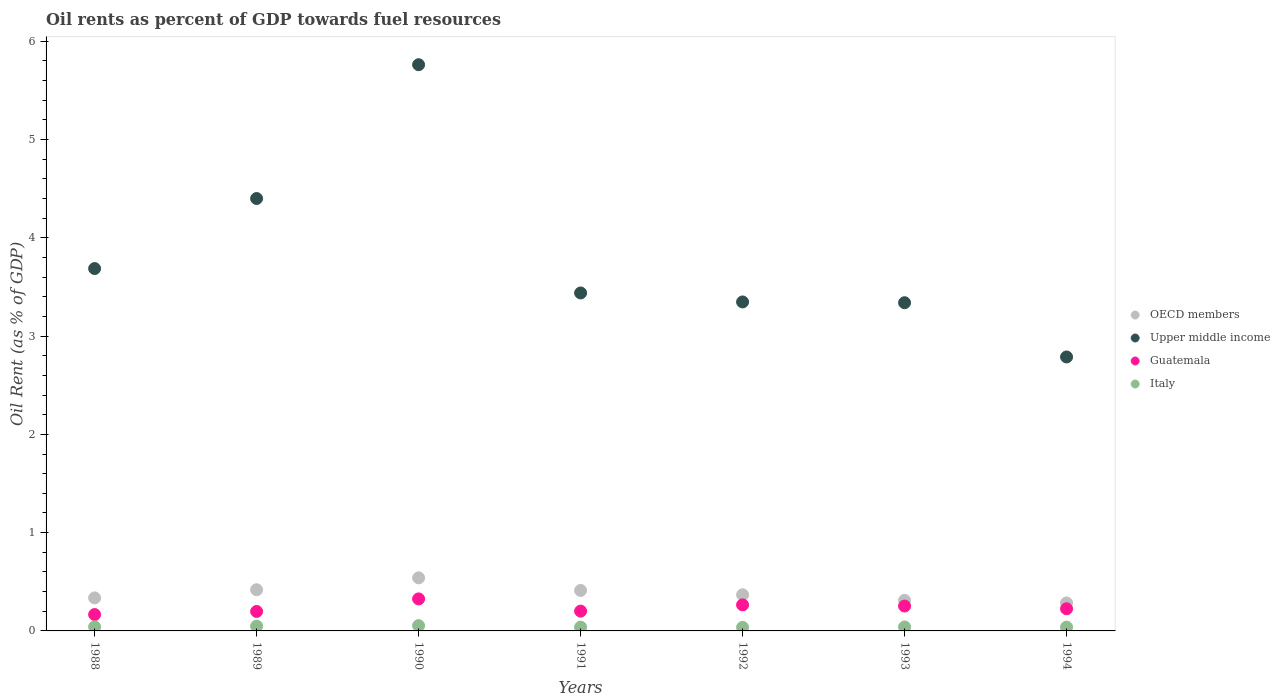How many different coloured dotlines are there?
Provide a short and direct response. 4. What is the oil rent in OECD members in 1993?
Provide a short and direct response. 0.31. Across all years, what is the maximum oil rent in Italy?
Ensure brevity in your answer.  0.05. Across all years, what is the minimum oil rent in Upper middle income?
Make the answer very short. 2.79. In which year was the oil rent in Guatemala minimum?
Ensure brevity in your answer.  1988. What is the total oil rent in Guatemala in the graph?
Keep it short and to the point. 1.64. What is the difference between the oil rent in Italy in 1988 and that in 1990?
Make the answer very short. -0.01. What is the difference between the oil rent in Italy in 1988 and the oil rent in Guatemala in 1990?
Make the answer very short. -0.28. What is the average oil rent in Guatemala per year?
Make the answer very short. 0.23. In the year 1990, what is the difference between the oil rent in Guatemala and oil rent in Italy?
Make the answer very short. 0.27. What is the ratio of the oil rent in Italy in 1991 to that in 1992?
Offer a terse response. 1.06. What is the difference between the highest and the second highest oil rent in Upper middle income?
Ensure brevity in your answer.  1.36. What is the difference between the highest and the lowest oil rent in Upper middle income?
Ensure brevity in your answer.  2.97. Is the sum of the oil rent in OECD members in 1992 and 1993 greater than the maximum oil rent in Italy across all years?
Make the answer very short. Yes. Is it the case that in every year, the sum of the oil rent in Italy and oil rent in OECD members  is greater than the sum of oil rent in Guatemala and oil rent in Upper middle income?
Your response must be concise. Yes. Is the oil rent in Upper middle income strictly greater than the oil rent in Italy over the years?
Keep it short and to the point. Yes. Is the oil rent in OECD members strictly less than the oil rent in Upper middle income over the years?
Keep it short and to the point. Yes. How many years are there in the graph?
Keep it short and to the point. 7. How many legend labels are there?
Your response must be concise. 4. What is the title of the graph?
Give a very brief answer. Oil rents as percent of GDP towards fuel resources. Does "Afghanistan" appear as one of the legend labels in the graph?
Give a very brief answer. No. What is the label or title of the X-axis?
Your response must be concise. Years. What is the label or title of the Y-axis?
Offer a very short reply. Oil Rent (as % of GDP). What is the Oil Rent (as % of GDP) in OECD members in 1988?
Ensure brevity in your answer.  0.34. What is the Oil Rent (as % of GDP) in Upper middle income in 1988?
Provide a succinct answer. 3.69. What is the Oil Rent (as % of GDP) of Guatemala in 1988?
Provide a short and direct response. 0.17. What is the Oil Rent (as % of GDP) of Italy in 1988?
Provide a short and direct response. 0.04. What is the Oil Rent (as % of GDP) of OECD members in 1989?
Make the answer very short. 0.42. What is the Oil Rent (as % of GDP) of Upper middle income in 1989?
Your answer should be compact. 4.4. What is the Oil Rent (as % of GDP) in Guatemala in 1989?
Provide a succinct answer. 0.2. What is the Oil Rent (as % of GDP) of Italy in 1989?
Provide a short and direct response. 0.05. What is the Oil Rent (as % of GDP) in OECD members in 1990?
Offer a terse response. 0.54. What is the Oil Rent (as % of GDP) of Upper middle income in 1990?
Make the answer very short. 5.76. What is the Oil Rent (as % of GDP) in Guatemala in 1990?
Your response must be concise. 0.33. What is the Oil Rent (as % of GDP) of Italy in 1990?
Provide a short and direct response. 0.05. What is the Oil Rent (as % of GDP) of OECD members in 1991?
Provide a succinct answer. 0.41. What is the Oil Rent (as % of GDP) in Upper middle income in 1991?
Your answer should be very brief. 3.44. What is the Oil Rent (as % of GDP) in Guatemala in 1991?
Give a very brief answer. 0.2. What is the Oil Rent (as % of GDP) of Italy in 1991?
Offer a terse response. 0.04. What is the Oil Rent (as % of GDP) of OECD members in 1992?
Give a very brief answer. 0.37. What is the Oil Rent (as % of GDP) in Upper middle income in 1992?
Give a very brief answer. 3.35. What is the Oil Rent (as % of GDP) in Guatemala in 1992?
Your response must be concise. 0.27. What is the Oil Rent (as % of GDP) in Italy in 1992?
Give a very brief answer. 0.04. What is the Oil Rent (as % of GDP) of OECD members in 1993?
Keep it short and to the point. 0.31. What is the Oil Rent (as % of GDP) in Upper middle income in 1993?
Offer a very short reply. 3.34. What is the Oil Rent (as % of GDP) of Guatemala in 1993?
Your answer should be compact. 0.25. What is the Oil Rent (as % of GDP) in Italy in 1993?
Give a very brief answer. 0.04. What is the Oil Rent (as % of GDP) in OECD members in 1994?
Keep it short and to the point. 0.28. What is the Oil Rent (as % of GDP) of Upper middle income in 1994?
Offer a very short reply. 2.79. What is the Oil Rent (as % of GDP) of Guatemala in 1994?
Offer a terse response. 0.23. What is the Oil Rent (as % of GDP) in Italy in 1994?
Make the answer very short. 0.04. Across all years, what is the maximum Oil Rent (as % of GDP) in OECD members?
Your response must be concise. 0.54. Across all years, what is the maximum Oil Rent (as % of GDP) of Upper middle income?
Your response must be concise. 5.76. Across all years, what is the maximum Oil Rent (as % of GDP) in Guatemala?
Offer a very short reply. 0.33. Across all years, what is the maximum Oil Rent (as % of GDP) in Italy?
Your answer should be compact. 0.05. Across all years, what is the minimum Oil Rent (as % of GDP) in OECD members?
Make the answer very short. 0.28. Across all years, what is the minimum Oil Rent (as % of GDP) in Upper middle income?
Make the answer very short. 2.79. Across all years, what is the minimum Oil Rent (as % of GDP) in Guatemala?
Offer a very short reply. 0.17. Across all years, what is the minimum Oil Rent (as % of GDP) of Italy?
Provide a short and direct response. 0.04. What is the total Oil Rent (as % of GDP) in OECD members in the graph?
Offer a terse response. 2.67. What is the total Oil Rent (as % of GDP) in Upper middle income in the graph?
Make the answer very short. 26.76. What is the total Oil Rent (as % of GDP) of Guatemala in the graph?
Make the answer very short. 1.64. What is the total Oil Rent (as % of GDP) of Italy in the graph?
Make the answer very short. 0.3. What is the difference between the Oil Rent (as % of GDP) in OECD members in 1988 and that in 1989?
Ensure brevity in your answer.  -0.08. What is the difference between the Oil Rent (as % of GDP) of Upper middle income in 1988 and that in 1989?
Your response must be concise. -0.71. What is the difference between the Oil Rent (as % of GDP) of Guatemala in 1988 and that in 1989?
Your answer should be very brief. -0.03. What is the difference between the Oil Rent (as % of GDP) of Italy in 1988 and that in 1989?
Offer a terse response. -0.01. What is the difference between the Oil Rent (as % of GDP) in OECD members in 1988 and that in 1990?
Make the answer very short. -0.2. What is the difference between the Oil Rent (as % of GDP) in Upper middle income in 1988 and that in 1990?
Your answer should be very brief. -2.07. What is the difference between the Oil Rent (as % of GDP) in Guatemala in 1988 and that in 1990?
Offer a terse response. -0.16. What is the difference between the Oil Rent (as % of GDP) in Italy in 1988 and that in 1990?
Keep it short and to the point. -0.01. What is the difference between the Oil Rent (as % of GDP) in OECD members in 1988 and that in 1991?
Your answer should be compact. -0.08. What is the difference between the Oil Rent (as % of GDP) of Upper middle income in 1988 and that in 1991?
Provide a succinct answer. 0.25. What is the difference between the Oil Rent (as % of GDP) of Guatemala in 1988 and that in 1991?
Your answer should be compact. -0.03. What is the difference between the Oil Rent (as % of GDP) in Italy in 1988 and that in 1991?
Give a very brief answer. 0. What is the difference between the Oil Rent (as % of GDP) of OECD members in 1988 and that in 1992?
Your answer should be compact. -0.03. What is the difference between the Oil Rent (as % of GDP) of Upper middle income in 1988 and that in 1992?
Give a very brief answer. 0.34. What is the difference between the Oil Rent (as % of GDP) in Guatemala in 1988 and that in 1992?
Your answer should be compact. -0.1. What is the difference between the Oil Rent (as % of GDP) in Italy in 1988 and that in 1992?
Ensure brevity in your answer.  0.01. What is the difference between the Oil Rent (as % of GDP) in OECD members in 1988 and that in 1993?
Offer a terse response. 0.03. What is the difference between the Oil Rent (as % of GDP) in Upper middle income in 1988 and that in 1993?
Keep it short and to the point. 0.35. What is the difference between the Oil Rent (as % of GDP) of Guatemala in 1988 and that in 1993?
Offer a very short reply. -0.09. What is the difference between the Oil Rent (as % of GDP) of Italy in 1988 and that in 1993?
Make the answer very short. 0. What is the difference between the Oil Rent (as % of GDP) in OECD members in 1988 and that in 1994?
Keep it short and to the point. 0.05. What is the difference between the Oil Rent (as % of GDP) of Upper middle income in 1988 and that in 1994?
Your answer should be compact. 0.9. What is the difference between the Oil Rent (as % of GDP) of Guatemala in 1988 and that in 1994?
Ensure brevity in your answer.  -0.06. What is the difference between the Oil Rent (as % of GDP) in Italy in 1988 and that in 1994?
Provide a succinct answer. 0. What is the difference between the Oil Rent (as % of GDP) in OECD members in 1989 and that in 1990?
Give a very brief answer. -0.12. What is the difference between the Oil Rent (as % of GDP) in Upper middle income in 1989 and that in 1990?
Offer a terse response. -1.36. What is the difference between the Oil Rent (as % of GDP) of Guatemala in 1989 and that in 1990?
Your answer should be compact. -0.13. What is the difference between the Oil Rent (as % of GDP) of Italy in 1989 and that in 1990?
Your answer should be compact. -0.01. What is the difference between the Oil Rent (as % of GDP) of OECD members in 1989 and that in 1991?
Your answer should be very brief. 0.01. What is the difference between the Oil Rent (as % of GDP) in Upper middle income in 1989 and that in 1991?
Your answer should be very brief. 0.96. What is the difference between the Oil Rent (as % of GDP) of Guatemala in 1989 and that in 1991?
Provide a short and direct response. -0. What is the difference between the Oil Rent (as % of GDP) in Italy in 1989 and that in 1991?
Your answer should be very brief. 0.01. What is the difference between the Oil Rent (as % of GDP) in OECD members in 1989 and that in 1992?
Your response must be concise. 0.05. What is the difference between the Oil Rent (as % of GDP) in Upper middle income in 1989 and that in 1992?
Keep it short and to the point. 1.05. What is the difference between the Oil Rent (as % of GDP) in Guatemala in 1989 and that in 1992?
Provide a succinct answer. -0.07. What is the difference between the Oil Rent (as % of GDP) in Italy in 1989 and that in 1992?
Offer a terse response. 0.01. What is the difference between the Oil Rent (as % of GDP) in OECD members in 1989 and that in 1993?
Offer a terse response. 0.11. What is the difference between the Oil Rent (as % of GDP) of Upper middle income in 1989 and that in 1993?
Your answer should be compact. 1.06. What is the difference between the Oil Rent (as % of GDP) in Guatemala in 1989 and that in 1993?
Ensure brevity in your answer.  -0.05. What is the difference between the Oil Rent (as % of GDP) in Italy in 1989 and that in 1993?
Keep it short and to the point. 0.01. What is the difference between the Oil Rent (as % of GDP) in OECD members in 1989 and that in 1994?
Your response must be concise. 0.13. What is the difference between the Oil Rent (as % of GDP) of Upper middle income in 1989 and that in 1994?
Make the answer very short. 1.61. What is the difference between the Oil Rent (as % of GDP) of Guatemala in 1989 and that in 1994?
Ensure brevity in your answer.  -0.03. What is the difference between the Oil Rent (as % of GDP) in Italy in 1989 and that in 1994?
Keep it short and to the point. 0.01. What is the difference between the Oil Rent (as % of GDP) of OECD members in 1990 and that in 1991?
Give a very brief answer. 0.13. What is the difference between the Oil Rent (as % of GDP) of Upper middle income in 1990 and that in 1991?
Your answer should be very brief. 2.32. What is the difference between the Oil Rent (as % of GDP) of Guatemala in 1990 and that in 1991?
Offer a very short reply. 0.12. What is the difference between the Oil Rent (as % of GDP) in Italy in 1990 and that in 1991?
Ensure brevity in your answer.  0.02. What is the difference between the Oil Rent (as % of GDP) in OECD members in 1990 and that in 1992?
Your answer should be very brief. 0.17. What is the difference between the Oil Rent (as % of GDP) of Upper middle income in 1990 and that in 1992?
Offer a very short reply. 2.41. What is the difference between the Oil Rent (as % of GDP) of Guatemala in 1990 and that in 1992?
Your answer should be compact. 0.06. What is the difference between the Oil Rent (as % of GDP) in Italy in 1990 and that in 1992?
Provide a short and direct response. 0.02. What is the difference between the Oil Rent (as % of GDP) of OECD members in 1990 and that in 1993?
Offer a terse response. 0.23. What is the difference between the Oil Rent (as % of GDP) in Upper middle income in 1990 and that in 1993?
Ensure brevity in your answer.  2.42. What is the difference between the Oil Rent (as % of GDP) in Guatemala in 1990 and that in 1993?
Your answer should be compact. 0.07. What is the difference between the Oil Rent (as % of GDP) in Italy in 1990 and that in 1993?
Give a very brief answer. 0.01. What is the difference between the Oil Rent (as % of GDP) in OECD members in 1990 and that in 1994?
Offer a very short reply. 0.26. What is the difference between the Oil Rent (as % of GDP) in Upper middle income in 1990 and that in 1994?
Offer a terse response. 2.97. What is the difference between the Oil Rent (as % of GDP) of Guatemala in 1990 and that in 1994?
Your answer should be very brief. 0.1. What is the difference between the Oil Rent (as % of GDP) in Italy in 1990 and that in 1994?
Make the answer very short. 0.02. What is the difference between the Oil Rent (as % of GDP) in OECD members in 1991 and that in 1992?
Your answer should be compact. 0.04. What is the difference between the Oil Rent (as % of GDP) in Upper middle income in 1991 and that in 1992?
Offer a very short reply. 0.09. What is the difference between the Oil Rent (as % of GDP) in Guatemala in 1991 and that in 1992?
Your answer should be compact. -0.06. What is the difference between the Oil Rent (as % of GDP) of Italy in 1991 and that in 1992?
Offer a very short reply. 0. What is the difference between the Oil Rent (as % of GDP) in OECD members in 1991 and that in 1993?
Provide a succinct answer. 0.1. What is the difference between the Oil Rent (as % of GDP) in Upper middle income in 1991 and that in 1993?
Make the answer very short. 0.1. What is the difference between the Oil Rent (as % of GDP) of Guatemala in 1991 and that in 1993?
Make the answer very short. -0.05. What is the difference between the Oil Rent (as % of GDP) of Italy in 1991 and that in 1993?
Keep it short and to the point. -0. What is the difference between the Oil Rent (as % of GDP) of OECD members in 1991 and that in 1994?
Keep it short and to the point. 0.13. What is the difference between the Oil Rent (as % of GDP) of Upper middle income in 1991 and that in 1994?
Keep it short and to the point. 0.65. What is the difference between the Oil Rent (as % of GDP) in Guatemala in 1991 and that in 1994?
Make the answer very short. -0.02. What is the difference between the Oil Rent (as % of GDP) in Italy in 1991 and that in 1994?
Offer a terse response. 0. What is the difference between the Oil Rent (as % of GDP) of OECD members in 1992 and that in 1993?
Make the answer very short. 0.06. What is the difference between the Oil Rent (as % of GDP) in Upper middle income in 1992 and that in 1993?
Provide a succinct answer. 0.01. What is the difference between the Oil Rent (as % of GDP) in Guatemala in 1992 and that in 1993?
Offer a very short reply. 0.01. What is the difference between the Oil Rent (as % of GDP) in Italy in 1992 and that in 1993?
Offer a terse response. -0. What is the difference between the Oil Rent (as % of GDP) of OECD members in 1992 and that in 1994?
Offer a very short reply. 0.08. What is the difference between the Oil Rent (as % of GDP) of Upper middle income in 1992 and that in 1994?
Provide a succinct answer. 0.56. What is the difference between the Oil Rent (as % of GDP) in Guatemala in 1992 and that in 1994?
Offer a very short reply. 0.04. What is the difference between the Oil Rent (as % of GDP) in Italy in 1992 and that in 1994?
Offer a very short reply. -0. What is the difference between the Oil Rent (as % of GDP) in OECD members in 1993 and that in 1994?
Keep it short and to the point. 0.03. What is the difference between the Oil Rent (as % of GDP) in Upper middle income in 1993 and that in 1994?
Ensure brevity in your answer.  0.55. What is the difference between the Oil Rent (as % of GDP) of Guatemala in 1993 and that in 1994?
Offer a terse response. 0.03. What is the difference between the Oil Rent (as % of GDP) of Italy in 1993 and that in 1994?
Offer a terse response. 0. What is the difference between the Oil Rent (as % of GDP) of OECD members in 1988 and the Oil Rent (as % of GDP) of Upper middle income in 1989?
Offer a terse response. -4.06. What is the difference between the Oil Rent (as % of GDP) of OECD members in 1988 and the Oil Rent (as % of GDP) of Guatemala in 1989?
Provide a short and direct response. 0.14. What is the difference between the Oil Rent (as % of GDP) of OECD members in 1988 and the Oil Rent (as % of GDP) of Italy in 1989?
Give a very brief answer. 0.29. What is the difference between the Oil Rent (as % of GDP) in Upper middle income in 1988 and the Oil Rent (as % of GDP) in Guatemala in 1989?
Keep it short and to the point. 3.49. What is the difference between the Oil Rent (as % of GDP) in Upper middle income in 1988 and the Oil Rent (as % of GDP) in Italy in 1989?
Your answer should be compact. 3.64. What is the difference between the Oil Rent (as % of GDP) in Guatemala in 1988 and the Oil Rent (as % of GDP) in Italy in 1989?
Make the answer very short. 0.12. What is the difference between the Oil Rent (as % of GDP) in OECD members in 1988 and the Oil Rent (as % of GDP) in Upper middle income in 1990?
Keep it short and to the point. -5.43. What is the difference between the Oil Rent (as % of GDP) in OECD members in 1988 and the Oil Rent (as % of GDP) in Guatemala in 1990?
Your answer should be compact. 0.01. What is the difference between the Oil Rent (as % of GDP) in OECD members in 1988 and the Oil Rent (as % of GDP) in Italy in 1990?
Your response must be concise. 0.28. What is the difference between the Oil Rent (as % of GDP) in Upper middle income in 1988 and the Oil Rent (as % of GDP) in Guatemala in 1990?
Give a very brief answer. 3.36. What is the difference between the Oil Rent (as % of GDP) of Upper middle income in 1988 and the Oil Rent (as % of GDP) of Italy in 1990?
Your answer should be very brief. 3.63. What is the difference between the Oil Rent (as % of GDP) of Guatemala in 1988 and the Oil Rent (as % of GDP) of Italy in 1990?
Keep it short and to the point. 0.11. What is the difference between the Oil Rent (as % of GDP) in OECD members in 1988 and the Oil Rent (as % of GDP) in Upper middle income in 1991?
Provide a short and direct response. -3.1. What is the difference between the Oil Rent (as % of GDP) of OECD members in 1988 and the Oil Rent (as % of GDP) of Guatemala in 1991?
Ensure brevity in your answer.  0.13. What is the difference between the Oil Rent (as % of GDP) in OECD members in 1988 and the Oil Rent (as % of GDP) in Italy in 1991?
Make the answer very short. 0.3. What is the difference between the Oil Rent (as % of GDP) of Upper middle income in 1988 and the Oil Rent (as % of GDP) of Guatemala in 1991?
Ensure brevity in your answer.  3.49. What is the difference between the Oil Rent (as % of GDP) of Upper middle income in 1988 and the Oil Rent (as % of GDP) of Italy in 1991?
Ensure brevity in your answer.  3.65. What is the difference between the Oil Rent (as % of GDP) in Guatemala in 1988 and the Oil Rent (as % of GDP) in Italy in 1991?
Offer a terse response. 0.13. What is the difference between the Oil Rent (as % of GDP) of OECD members in 1988 and the Oil Rent (as % of GDP) of Upper middle income in 1992?
Ensure brevity in your answer.  -3.01. What is the difference between the Oil Rent (as % of GDP) of OECD members in 1988 and the Oil Rent (as % of GDP) of Guatemala in 1992?
Your answer should be compact. 0.07. What is the difference between the Oil Rent (as % of GDP) of OECD members in 1988 and the Oil Rent (as % of GDP) of Italy in 1992?
Offer a very short reply. 0.3. What is the difference between the Oil Rent (as % of GDP) of Upper middle income in 1988 and the Oil Rent (as % of GDP) of Guatemala in 1992?
Your answer should be compact. 3.42. What is the difference between the Oil Rent (as % of GDP) of Upper middle income in 1988 and the Oil Rent (as % of GDP) of Italy in 1992?
Provide a succinct answer. 3.65. What is the difference between the Oil Rent (as % of GDP) in Guatemala in 1988 and the Oil Rent (as % of GDP) in Italy in 1992?
Keep it short and to the point. 0.13. What is the difference between the Oil Rent (as % of GDP) in OECD members in 1988 and the Oil Rent (as % of GDP) in Upper middle income in 1993?
Your answer should be very brief. -3. What is the difference between the Oil Rent (as % of GDP) in OECD members in 1988 and the Oil Rent (as % of GDP) in Guatemala in 1993?
Make the answer very short. 0.08. What is the difference between the Oil Rent (as % of GDP) of OECD members in 1988 and the Oil Rent (as % of GDP) of Italy in 1993?
Provide a short and direct response. 0.3. What is the difference between the Oil Rent (as % of GDP) in Upper middle income in 1988 and the Oil Rent (as % of GDP) in Guatemala in 1993?
Give a very brief answer. 3.43. What is the difference between the Oil Rent (as % of GDP) of Upper middle income in 1988 and the Oil Rent (as % of GDP) of Italy in 1993?
Offer a very short reply. 3.65. What is the difference between the Oil Rent (as % of GDP) in Guatemala in 1988 and the Oil Rent (as % of GDP) in Italy in 1993?
Keep it short and to the point. 0.13. What is the difference between the Oil Rent (as % of GDP) in OECD members in 1988 and the Oil Rent (as % of GDP) in Upper middle income in 1994?
Provide a succinct answer. -2.45. What is the difference between the Oil Rent (as % of GDP) in OECD members in 1988 and the Oil Rent (as % of GDP) in Guatemala in 1994?
Your answer should be very brief. 0.11. What is the difference between the Oil Rent (as % of GDP) of OECD members in 1988 and the Oil Rent (as % of GDP) of Italy in 1994?
Your answer should be compact. 0.3. What is the difference between the Oil Rent (as % of GDP) of Upper middle income in 1988 and the Oil Rent (as % of GDP) of Guatemala in 1994?
Your response must be concise. 3.46. What is the difference between the Oil Rent (as % of GDP) of Upper middle income in 1988 and the Oil Rent (as % of GDP) of Italy in 1994?
Your answer should be very brief. 3.65. What is the difference between the Oil Rent (as % of GDP) of Guatemala in 1988 and the Oil Rent (as % of GDP) of Italy in 1994?
Your answer should be compact. 0.13. What is the difference between the Oil Rent (as % of GDP) in OECD members in 1989 and the Oil Rent (as % of GDP) in Upper middle income in 1990?
Keep it short and to the point. -5.34. What is the difference between the Oil Rent (as % of GDP) in OECD members in 1989 and the Oil Rent (as % of GDP) in Guatemala in 1990?
Your answer should be compact. 0.09. What is the difference between the Oil Rent (as % of GDP) of OECD members in 1989 and the Oil Rent (as % of GDP) of Italy in 1990?
Ensure brevity in your answer.  0.36. What is the difference between the Oil Rent (as % of GDP) of Upper middle income in 1989 and the Oil Rent (as % of GDP) of Guatemala in 1990?
Provide a succinct answer. 4.07. What is the difference between the Oil Rent (as % of GDP) of Upper middle income in 1989 and the Oil Rent (as % of GDP) of Italy in 1990?
Your answer should be compact. 4.35. What is the difference between the Oil Rent (as % of GDP) in Guatemala in 1989 and the Oil Rent (as % of GDP) in Italy in 1990?
Provide a succinct answer. 0.14. What is the difference between the Oil Rent (as % of GDP) in OECD members in 1989 and the Oil Rent (as % of GDP) in Upper middle income in 1991?
Your response must be concise. -3.02. What is the difference between the Oil Rent (as % of GDP) of OECD members in 1989 and the Oil Rent (as % of GDP) of Guatemala in 1991?
Make the answer very short. 0.22. What is the difference between the Oil Rent (as % of GDP) of OECD members in 1989 and the Oil Rent (as % of GDP) of Italy in 1991?
Provide a succinct answer. 0.38. What is the difference between the Oil Rent (as % of GDP) of Upper middle income in 1989 and the Oil Rent (as % of GDP) of Guatemala in 1991?
Offer a terse response. 4.2. What is the difference between the Oil Rent (as % of GDP) of Upper middle income in 1989 and the Oil Rent (as % of GDP) of Italy in 1991?
Your response must be concise. 4.36. What is the difference between the Oil Rent (as % of GDP) of Guatemala in 1989 and the Oil Rent (as % of GDP) of Italy in 1991?
Provide a succinct answer. 0.16. What is the difference between the Oil Rent (as % of GDP) of OECD members in 1989 and the Oil Rent (as % of GDP) of Upper middle income in 1992?
Make the answer very short. -2.93. What is the difference between the Oil Rent (as % of GDP) in OECD members in 1989 and the Oil Rent (as % of GDP) in Guatemala in 1992?
Ensure brevity in your answer.  0.15. What is the difference between the Oil Rent (as % of GDP) in OECD members in 1989 and the Oil Rent (as % of GDP) in Italy in 1992?
Your answer should be very brief. 0.38. What is the difference between the Oil Rent (as % of GDP) of Upper middle income in 1989 and the Oil Rent (as % of GDP) of Guatemala in 1992?
Make the answer very short. 4.13. What is the difference between the Oil Rent (as % of GDP) in Upper middle income in 1989 and the Oil Rent (as % of GDP) in Italy in 1992?
Offer a very short reply. 4.36. What is the difference between the Oil Rent (as % of GDP) in Guatemala in 1989 and the Oil Rent (as % of GDP) in Italy in 1992?
Ensure brevity in your answer.  0.16. What is the difference between the Oil Rent (as % of GDP) of OECD members in 1989 and the Oil Rent (as % of GDP) of Upper middle income in 1993?
Make the answer very short. -2.92. What is the difference between the Oil Rent (as % of GDP) in OECD members in 1989 and the Oil Rent (as % of GDP) in Guatemala in 1993?
Ensure brevity in your answer.  0.17. What is the difference between the Oil Rent (as % of GDP) in OECD members in 1989 and the Oil Rent (as % of GDP) in Italy in 1993?
Give a very brief answer. 0.38. What is the difference between the Oil Rent (as % of GDP) of Upper middle income in 1989 and the Oil Rent (as % of GDP) of Guatemala in 1993?
Provide a succinct answer. 4.15. What is the difference between the Oil Rent (as % of GDP) in Upper middle income in 1989 and the Oil Rent (as % of GDP) in Italy in 1993?
Offer a very short reply. 4.36. What is the difference between the Oil Rent (as % of GDP) in Guatemala in 1989 and the Oil Rent (as % of GDP) in Italy in 1993?
Provide a short and direct response. 0.16. What is the difference between the Oil Rent (as % of GDP) in OECD members in 1989 and the Oil Rent (as % of GDP) in Upper middle income in 1994?
Make the answer very short. -2.37. What is the difference between the Oil Rent (as % of GDP) in OECD members in 1989 and the Oil Rent (as % of GDP) in Guatemala in 1994?
Offer a terse response. 0.19. What is the difference between the Oil Rent (as % of GDP) of OECD members in 1989 and the Oil Rent (as % of GDP) of Italy in 1994?
Ensure brevity in your answer.  0.38. What is the difference between the Oil Rent (as % of GDP) in Upper middle income in 1989 and the Oil Rent (as % of GDP) in Guatemala in 1994?
Your response must be concise. 4.17. What is the difference between the Oil Rent (as % of GDP) in Upper middle income in 1989 and the Oil Rent (as % of GDP) in Italy in 1994?
Ensure brevity in your answer.  4.36. What is the difference between the Oil Rent (as % of GDP) in Guatemala in 1989 and the Oil Rent (as % of GDP) in Italy in 1994?
Ensure brevity in your answer.  0.16. What is the difference between the Oil Rent (as % of GDP) of OECD members in 1990 and the Oil Rent (as % of GDP) of Upper middle income in 1991?
Keep it short and to the point. -2.9. What is the difference between the Oil Rent (as % of GDP) of OECD members in 1990 and the Oil Rent (as % of GDP) of Guatemala in 1991?
Offer a terse response. 0.34. What is the difference between the Oil Rent (as % of GDP) of OECD members in 1990 and the Oil Rent (as % of GDP) of Italy in 1991?
Make the answer very short. 0.5. What is the difference between the Oil Rent (as % of GDP) in Upper middle income in 1990 and the Oil Rent (as % of GDP) in Guatemala in 1991?
Offer a very short reply. 5.56. What is the difference between the Oil Rent (as % of GDP) of Upper middle income in 1990 and the Oil Rent (as % of GDP) of Italy in 1991?
Provide a short and direct response. 5.72. What is the difference between the Oil Rent (as % of GDP) in Guatemala in 1990 and the Oil Rent (as % of GDP) in Italy in 1991?
Your answer should be very brief. 0.29. What is the difference between the Oil Rent (as % of GDP) in OECD members in 1990 and the Oil Rent (as % of GDP) in Upper middle income in 1992?
Your answer should be compact. -2.81. What is the difference between the Oil Rent (as % of GDP) of OECD members in 1990 and the Oil Rent (as % of GDP) of Guatemala in 1992?
Offer a very short reply. 0.28. What is the difference between the Oil Rent (as % of GDP) of OECD members in 1990 and the Oil Rent (as % of GDP) of Italy in 1992?
Provide a succinct answer. 0.5. What is the difference between the Oil Rent (as % of GDP) of Upper middle income in 1990 and the Oil Rent (as % of GDP) of Guatemala in 1992?
Your answer should be very brief. 5.5. What is the difference between the Oil Rent (as % of GDP) in Upper middle income in 1990 and the Oil Rent (as % of GDP) in Italy in 1992?
Give a very brief answer. 5.73. What is the difference between the Oil Rent (as % of GDP) of Guatemala in 1990 and the Oil Rent (as % of GDP) of Italy in 1992?
Keep it short and to the point. 0.29. What is the difference between the Oil Rent (as % of GDP) in OECD members in 1990 and the Oil Rent (as % of GDP) in Upper middle income in 1993?
Your response must be concise. -2.8. What is the difference between the Oil Rent (as % of GDP) of OECD members in 1990 and the Oil Rent (as % of GDP) of Guatemala in 1993?
Make the answer very short. 0.29. What is the difference between the Oil Rent (as % of GDP) of OECD members in 1990 and the Oil Rent (as % of GDP) of Italy in 1993?
Make the answer very short. 0.5. What is the difference between the Oil Rent (as % of GDP) in Upper middle income in 1990 and the Oil Rent (as % of GDP) in Guatemala in 1993?
Make the answer very short. 5.51. What is the difference between the Oil Rent (as % of GDP) of Upper middle income in 1990 and the Oil Rent (as % of GDP) of Italy in 1993?
Provide a succinct answer. 5.72. What is the difference between the Oil Rent (as % of GDP) of Guatemala in 1990 and the Oil Rent (as % of GDP) of Italy in 1993?
Provide a short and direct response. 0.29. What is the difference between the Oil Rent (as % of GDP) in OECD members in 1990 and the Oil Rent (as % of GDP) in Upper middle income in 1994?
Ensure brevity in your answer.  -2.25. What is the difference between the Oil Rent (as % of GDP) in OECD members in 1990 and the Oil Rent (as % of GDP) in Guatemala in 1994?
Your answer should be very brief. 0.31. What is the difference between the Oil Rent (as % of GDP) of OECD members in 1990 and the Oil Rent (as % of GDP) of Italy in 1994?
Offer a very short reply. 0.5. What is the difference between the Oil Rent (as % of GDP) in Upper middle income in 1990 and the Oil Rent (as % of GDP) in Guatemala in 1994?
Keep it short and to the point. 5.54. What is the difference between the Oil Rent (as % of GDP) of Upper middle income in 1990 and the Oil Rent (as % of GDP) of Italy in 1994?
Offer a very short reply. 5.72. What is the difference between the Oil Rent (as % of GDP) of Guatemala in 1990 and the Oil Rent (as % of GDP) of Italy in 1994?
Offer a terse response. 0.29. What is the difference between the Oil Rent (as % of GDP) in OECD members in 1991 and the Oil Rent (as % of GDP) in Upper middle income in 1992?
Your answer should be very brief. -2.94. What is the difference between the Oil Rent (as % of GDP) of OECD members in 1991 and the Oil Rent (as % of GDP) of Guatemala in 1992?
Provide a succinct answer. 0.15. What is the difference between the Oil Rent (as % of GDP) in OECD members in 1991 and the Oil Rent (as % of GDP) in Italy in 1992?
Your answer should be very brief. 0.38. What is the difference between the Oil Rent (as % of GDP) of Upper middle income in 1991 and the Oil Rent (as % of GDP) of Guatemala in 1992?
Your answer should be very brief. 3.17. What is the difference between the Oil Rent (as % of GDP) of Upper middle income in 1991 and the Oil Rent (as % of GDP) of Italy in 1992?
Provide a succinct answer. 3.4. What is the difference between the Oil Rent (as % of GDP) of Guatemala in 1991 and the Oil Rent (as % of GDP) of Italy in 1992?
Keep it short and to the point. 0.17. What is the difference between the Oil Rent (as % of GDP) of OECD members in 1991 and the Oil Rent (as % of GDP) of Upper middle income in 1993?
Your response must be concise. -2.93. What is the difference between the Oil Rent (as % of GDP) of OECD members in 1991 and the Oil Rent (as % of GDP) of Guatemala in 1993?
Offer a terse response. 0.16. What is the difference between the Oil Rent (as % of GDP) in OECD members in 1991 and the Oil Rent (as % of GDP) in Italy in 1993?
Make the answer very short. 0.37. What is the difference between the Oil Rent (as % of GDP) in Upper middle income in 1991 and the Oil Rent (as % of GDP) in Guatemala in 1993?
Your answer should be compact. 3.19. What is the difference between the Oil Rent (as % of GDP) of Upper middle income in 1991 and the Oil Rent (as % of GDP) of Italy in 1993?
Keep it short and to the point. 3.4. What is the difference between the Oil Rent (as % of GDP) of Guatemala in 1991 and the Oil Rent (as % of GDP) of Italy in 1993?
Keep it short and to the point. 0.16. What is the difference between the Oil Rent (as % of GDP) of OECD members in 1991 and the Oil Rent (as % of GDP) of Upper middle income in 1994?
Make the answer very short. -2.38. What is the difference between the Oil Rent (as % of GDP) of OECD members in 1991 and the Oil Rent (as % of GDP) of Guatemala in 1994?
Offer a very short reply. 0.19. What is the difference between the Oil Rent (as % of GDP) in OECD members in 1991 and the Oil Rent (as % of GDP) in Italy in 1994?
Make the answer very short. 0.37. What is the difference between the Oil Rent (as % of GDP) in Upper middle income in 1991 and the Oil Rent (as % of GDP) in Guatemala in 1994?
Offer a very short reply. 3.21. What is the difference between the Oil Rent (as % of GDP) in Upper middle income in 1991 and the Oil Rent (as % of GDP) in Italy in 1994?
Your answer should be compact. 3.4. What is the difference between the Oil Rent (as % of GDP) in Guatemala in 1991 and the Oil Rent (as % of GDP) in Italy in 1994?
Ensure brevity in your answer.  0.16. What is the difference between the Oil Rent (as % of GDP) in OECD members in 1992 and the Oil Rent (as % of GDP) in Upper middle income in 1993?
Your answer should be compact. -2.97. What is the difference between the Oil Rent (as % of GDP) in OECD members in 1992 and the Oil Rent (as % of GDP) in Guatemala in 1993?
Make the answer very short. 0.11. What is the difference between the Oil Rent (as % of GDP) of OECD members in 1992 and the Oil Rent (as % of GDP) of Italy in 1993?
Offer a terse response. 0.33. What is the difference between the Oil Rent (as % of GDP) of Upper middle income in 1992 and the Oil Rent (as % of GDP) of Guatemala in 1993?
Ensure brevity in your answer.  3.09. What is the difference between the Oil Rent (as % of GDP) in Upper middle income in 1992 and the Oil Rent (as % of GDP) in Italy in 1993?
Offer a terse response. 3.31. What is the difference between the Oil Rent (as % of GDP) in Guatemala in 1992 and the Oil Rent (as % of GDP) in Italy in 1993?
Make the answer very short. 0.22. What is the difference between the Oil Rent (as % of GDP) of OECD members in 1992 and the Oil Rent (as % of GDP) of Upper middle income in 1994?
Provide a short and direct response. -2.42. What is the difference between the Oil Rent (as % of GDP) of OECD members in 1992 and the Oil Rent (as % of GDP) of Guatemala in 1994?
Your answer should be very brief. 0.14. What is the difference between the Oil Rent (as % of GDP) in OECD members in 1992 and the Oil Rent (as % of GDP) in Italy in 1994?
Ensure brevity in your answer.  0.33. What is the difference between the Oil Rent (as % of GDP) of Upper middle income in 1992 and the Oil Rent (as % of GDP) of Guatemala in 1994?
Ensure brevity in your answer.  3.12. What is the difference between the Oil Rent (as % of GDP) of Upper middle income in 1992 and the Oil Rent (as % of GDP) of Italy in 1994?
Provide a short and direct response. 3.31. What is the difference between the Oil Rent (as % of GDP) of Guatemala in 1992 and the Oil Rent (as % of GDP) of Italy in 1994?
Offer a terse response. 0.23. What is the difference between the Oil Rent (as % of GDP) of OECD members in 1993 and the Oil Rent (as % of GDP) of Upper middle income in 1994?
Offer a very short reply. -2.48. What is the difference between the Oil Rent (as % of GDP) of OECD members in 1993 and the Oil Rent (as % of GDP) of Guatemala in 1994?
Your answer should be compact. 0.09. What is the difference between the Oil Rent (as % of GDP) in OECD members in 1993 and the Oil Rent (as % of GDP) in Italy in 1994?
Keep it short and to the point. 0.27. What is the difference between the Oil Rent (as % of GDP) in Upper middle income in 1993 and the Oil Rent (as % of GDP) in Guatemala in 1994?
Ensure brevity in your answer.  3.11. What is the difference between the Oil Rent (as % of GDP) of Upper middle income in 1993 and the Oil Rent (as % of GDP) of Italy in 1994?
Your answer should be compact. 3.3. What is the difference between the Oil Rent (as % of GDP) in Guatemala in 1993 and the Oil Rent (as % of GDP) in Italy in 1994?
Your response must be concise. 0.21. What is the average Oil Rent (as % of GDP) in OECD members per year?
Make the answer very short. 0.38. What is the average Oil Rent (as % of GDP) in Upper middle income per year?
Make the answer very short. 3.82. What is the average Oil Rent (as % of GDP) of Guatemala per year?
Offer a very short reply. 0.23. What is the average Oil Rent (as % of GDP) of Italy per year?
Your response must be concise. 0.04. In the year 1988, what is the difference between the Oil Rent (as % of GDP) of OECD members and Oil Rent (as % of GDP) of Upper middle income?
Give a very brief answer. -3.35. In the year 1988, what is the difference between the Oil Rent (as % of GDP) of OECD members and Oil Rent (as % of GDP) of Guatemala?
Your response must be concise. 0.17. In the year 1988, what is the difference between the Oil Rent (as % of GDP) in OECD members and Oil Rent (as % of GDP) in Italy?
Ensure brevity in your answer.  0.29. In the year 1988, what is the difference between the Oil Rent (as % of GDP) in Upper middle income and Oil Rent (as % of GDP) in Guatemala?
Keep it short and to the point. 3.52. In the year 1988, what is the difference between the Oil Rent (as % of GDP) of Upper middle income and Oil Rent (as % of GDP) of Italy?
Give a very brief answer. 3.65. In the year 1988, what is the difference between the Oil Rent (as % of GDP) of Guatemala and Oil Rent (as % of GDP) of Italy?
Your answer should be very brief. 0.13. In the year 1989, what is the difference between the Oil Rent (as % of GDP) of OECD members and Oil Rent (as % of GDP) of Upper middle income?
Provide a succinct answer. -3.98. In the year 1989, what is the difference between the Oil Rent (as % of GDP) in OECD members and Oil Rent (as % of GDP) in Guatemala?
Keep it short and to the point. 0.22. In the year 1989, what is the difference between the Oil Rent (as % of GDP) of OECD members and Oil Rent (as % of GDP) of Italy?
Provide a short and direct response. 0.37. In the year 1989, what is the difference between the Oil Rent (as % of GDP) of Upper middle income and Oil Rent (as % of GDP) of Guatemala?
Provide a short and direct response. 4.2. In the year 1989, what is the difference between the Oil Rent (as % of GDP) of Upper middle income and Oil Rent (as % of GDP) of Italy?
Your answer should be compact. 4.35. In the year 1989, what is the difference between the Oil Rent (as % of GDP) of Guatemala and Oil Rent (as % of GDP) of Italy?
Offer a terse response. 0.15. In the year 1990, what is the difference between the Oil Rent (as % of GDP) in OECD members and Oil Rent (as % of GDP) in Upper middle income?
Your response must be concise. -5.22. In the year 1990, what is the difference between the Oil Rent (as % of GDP) of OECD members and Oil Rent (as % of GDP) of Guatemala?
Provide a short and direct response. 0.21. In the year 1990, what is the difference between the Oil Rent (as % of GDP) of OECD members and Oil Rent (as % of GDP) of Italy?
Ensure brevity in your answer.  0.49. In the year 1990, what is the difference between the Oil Rent (as % of GDP) in Upper middle income and Oil Rent (as % of GDP) in Guatemala?
Offer a very short reply. 5.44. In the year 1990, what is the difference between the Oil Rent (as % of GDP) in Upper middle income and Oil Rent (as % of GDP) in Italy?
Offer a very short reply. 5.71. In the year 1990, what is the difference between the Oil Rent (as % of GDP) of Guatemala and Oil Rent (as % of GDP) of Italy?
Your response must be concise. 0.27. In the year 1991, what is the difference between the Oil Rent (as % of GDP) of OECD members and Oil Rent (as % of GDP) of Upper middle income?
Your answer should be compact. -3.03. In the year 1991, what is the difference between the Oil Rent (as % of GDP) of OECD members and Oil Rent (as % of GDP) of Guatemala?
Make the answer very short. 0.21. In the year 1991, what is the difference between the Oil Rent (as % of GDP) in OECD members and Oil Rent (as % of GDP) in Italy?
Provide a short and direct response. 0.37. In the year 1991, what is the difference between the Oil Rent (as % of GDP) of Upper middle income and Oil Rent (as % of GDP) of Guatemala?
Keep it short and to the point. 3.24. In the year 1991, what is the difference between the Oil Rent (as % of GDP) of Upper middle income and Oil Rent (as % of GDP) of Italy?
Offer a very short reply. 3.4. In the year 1991, what is the difference between the Oil Rent (as % of GDP) in Guatemala and Oil Rent (as % of GDP) in Italy?
Make the answer very short. 0.16. In the year 1992, what is the difference between the Oil Rent (as % of GDP) of OECD members and Oil Rent (as % of GDP) of Upper middle income?
Your answer should be very brief. -2.98. In the year 1992, what is the difference between the Oil Rent (as % of GDP) of OECD members and Oil Rent (as % of GDP) of Guatemala?
Make the answer very short. 0.1. In the year 1992, what is the difference between the Oil Rent (as % of GDP) in OECD members and Oil Rent (as % of GDP) in Italy?
Your answer should be very brief. 0.33. In the year 1992, what is the difference between the Oil Rent (as % of GDP) in Upper middle income and Oil Rent (as % of GDP) in Guatemala?
Your answer should be very brief. 3.08. In the year 1992, what is the difference between the Oil Rent (as % of GDP) of Upper middle income and Oil Rent (as % of GDP) of Italy?
Ensure brevity in your answer.  3.31. In the year 1992, what is the difference between the Oil Rent (as % of GDP) in Guatemala and Oil Rent (as % of GDP) in Italy?
Make the answer very short. 0.23. In the year 1993, what is the difference between the Oil Rent (as % of GDP) in OECD members and Oil Rent (as % of GDP) in Upper middle income?
Your answer should be very brief. -3.03. In the year 1993, what is the difference between the Oil Rent (as % of GDP) of OECD members and Oil Rent (as % of GDP) of Guatemala?
Your response must be concise. 0.06. In the year 1993, what is the difference between the Oil Rent (as % of GDP) of OECD members and Oil Rent (as % of GDP) of Italy?
Offer a terse response. 0.27. In the year 1993, what is the difference between the Oil Rent (as % of GDP) in Upper middle income and Oil Rent (as % of GDP) in Guatemala?
Offer a terse response. 3.09. In the year 1993, what is the difference between the Oil Rent (as % of GDP) of Upper middle income and Oil Rent (as % of GDP) of Italy?
Keep it short and to the point. 3.3. In the year 1993, what is the difference between the Oil Rent (as % of GDP) of Guatemala and Oil Rent (as % of GDP) of Italy?
Give a very brief answer. 0.21. In the year 1994, what is the difference between the Oil Rent (as % of GDP) of OECD members and Oil Rent (as % of GDP) of Upper middle income?
Give a very brief answer. -2.5. In the year 1994, what is the difference between the Oil Rent (as % of GDP) of OECD members and Oil Rent (as % of GDP) of Guatemala?
Your answer should be very brief. 0.06. In the year 1994, what is the difference between the Oil Rent (as % of GDP) of OECD members and Oil Rent (as % of GDP) of Italy?
Make the answer very short. 0.25. In the year 1994, what is the difference between the Oil Rent (as % of GDP) of Upper middle income and Oil Rent (as % of GDP) of Guatemala?
Your answer should be compact. 2.56. In the year 1994, what is the difference between the Oil Rent (as % of GDP) in Upper middle income and Oil Rent (as % of GDP) in Italy?
Ensure brevity in your answer.  2.75. In the year 1994, what is the difference between the Oil Rent (as % of GDP) of Guatemala and Oil Rent (as % of GDP) of Italy?
Give a very brief answer. 0.19. What is the ratio of the Oil Rent (as % of GDP) in OECD members in 1988 to that in 1989?
Your answer should be compact. 0.8. What is the ratio of the Oil Rent (as % of GDP) in Upper middle income in 1988 to that in 1989?
Keep it short and to the point. 0.84. What is the ratio of the Oil Rent (as % of GDP) in Guatemala in 1988 to that in 1989?
Make the answer very short. 0.84. What is the ratio of the Oil Rent (as % of GDP) in Italy in 1988 to that in 1989?
Your answer should be compact. 0.84. What is the ratio of the Oil Rent (as % of GDP) of OECD members in 1988 to that in 1990?
Your answer should be compact. 0.62. What is the ratio of the Oil Rent (as % of GDP) of Upper middle income in 1988 to that in 1990?
Offer a terse response. 0.64. What is the ratio of the Oil Rent (as % of GDP) of Guatemala in 1988 to that in 1990?
Your answer should be very brief. 0.51. What is the ratio of the Oil Rent (as % of GDP) of Italy in 1988 to that in 1990?
Ensure brevity in your answer.  0.76. What is the ratio of the Oil Rent (as % of GDP) in OECD members in 1988 to that in 1991?
Keep it short and to the point. 0.82. What is the ratio of the Oil Rent (as % of GDP) of Upper middle income in 1988 to that in 1991?
Provide a short and direct response. 1.07. What is the ratio of the Oil Rent (as % of GDP) of Guatemala in 1988 to that in 1991?
Your answer should be compact. 0.83. What is the ratio of the Oil Rent (as % of GDP) of Italy in 1988 to that in 1991?
Make the answer very short. 1.07. What is the ratio of the Oil Rent (as % of GDP) of OECD members in 1988 to that in 1992?
Provide a succinct answer. 0.91. What is the ratio of the Oil Rent (as % of GDP) of Upper middle income in 1988 to that in 1992?
Provide a succinct answer. 1.1. What is the ratio of the Oil Rent (as % of GDP) in Guatemala in 1988 to that in 1992?
Provide a short and direct response. 0.63. What is the ratio of the Oil Rent (as % of GDP) in Italy in 1988 to that in 1992?
Offer a terse response. 1.14. What is the ratio of the Oil Rent (as % of GDP) in OECD members in 1988 to that in 1993?
Give a very brief answer. 1.08. What is the ratio of the Oil Rent (as % of GDP) of Upper middle income in 1988 to that in 1993?
Your answer should be compact. 1.1. What is the ratio of the Oil Rent (as % of GDP) of Guatemala in 1988 to that in 1993?
Offer a very short reply. 0.66. What is the ratio of the Oil Rent (as % of GDP) of Italy in 1988 to that in 1993?
Ensure brevity in your answer.  1.03. What is the ratio of the Oil Rent (as % of GDP) of OECD members in 1988 to that in 1994?
Provide a succinct answer. 1.18. What is the ratio of the Oil Rent (as % of GDP) in Upper middle income in 1988 to that in 1994?
Provide a succinct answer. 1.32. What is the ratio of the Oil Rent (as % of GDP) in Guatemala in 1988 to that in 1994?
Your response must be concise. 0.74. What is the ratio of the Oil Rent (as % of GDP) of Italy in 1988 to that in 1994?
Provide a succinct answer. 1.08. What is the ratio of the Oil Rent (as % of GDP) of OECD members in 1989 to that in 1990?
Make the answer very short. 0.78. What is the ratio of the Oil Rent (as % of GDP) of Upper middle income in 1989 to that in 1990?
Ensure brevity in your answer.  0.76. What is the ratio of the Oil Rent (as % of GDP) in Guatemala in 1989 to that in 1990?
Your response must be concise. 0.61. What is the ratio of the Oil Rent (as % of GDP) of Italy in 1989 to that in 1990?
Your response must be concise. 0.9. What is the ratio of the Oil Rent (as % of GDP) in OECD members in 1989 to that in 1991?
Your answer should be compact. 1.02. What is the ratio of the Oil Rent (as % of GDP) of Upper middle income in 1989 to that in 1991?
Offer a terse response. 1.28. What is the ratio of the Oil Rent (as % of GDP) of Guatemala in 1989 to that in 1991?
Offer a very short reply. 0.98. What is the ratio of the Oil Rent (as % of GDP) of Italy in 1989 to that in 1991?
Your response must be concise. 1.27. What is the ratio of the Oil Rent (as % of GDP) in OECD members in 1989 to that in 1992?
Give a very brief answer. 1.14. What is the ratio of the Oil Rent (as % of GDP) of Upper middle income in 1989 to that in 1992?
Provide a succinct answer. 1.31. What is the ratio of the Oil Rent (as % of GDP) of Guatemala in 1989 to that in 1992?
Your answer should be very brief. 0.75. What is the ratio of the Oil Rent (as % of GDP) in Italy in 1989 to that in 1992?
Your answer should be compact. 1.35. What is the ratio of the Oil Rent (as % of GDP) of OECD members in 1989 to that in 1993?
Offer a very short reply. 1.35. What is the ratio of the Oil Rent (as % of GDP) of Upper middle income in 1989 to that in 1993?
Keep it short and to the point. 1.32. What is the ratio of the Oil Rent (as % of GDP) of Guatemala in 1989 to that in 1993?
Your answer should be compact. 0.78. What is the ratio of the Oil Rent (as % of GDP) of Italy in 1989 to that in 1993?
Offer a very short reply. 1.22. What is the ratio of the Oil Rent (as % of GDP) of OECD members in 1989 to that in 1994?
Provide a succinct answer. 1.47. What is the ratio of the Oil Rent (as % of GDP) in Upper middle income in 1989 to that in 1994?
Provide a succinct answer. 1.58. What is the ratio of the Oil Rent (as % of GDP) of Guatemala in 1989 to that in 1994?
Ensure brevity in your answer.  0.88. What is the ratio of the Oil Rent (as % of GDP) of Italy in 1989 to that in 1994?
Ensure brevity in your answer.  1.27. What is the ratio of the Oil Rent (as % of GDP) of OECD members in 1990 to that in 1991?
Your response must be concise. 1.31. What is the ratio of the Oil Rent (as % of GDP) of Upper middle income in 1990 to that in 1991?
Provide a succinct answer. 1.68. What is the ratio of the Oil Rent (as % of GDP) in Guatemala in 1990 to that in 1991?
Give a very brief answer. 1.62. What is the ratio of the Oil Rent (as % of GDP) in Italy in 1990 to that in 1991?
Make the answer very short. 1.41. What is the ratio of the Oil Rent (as % of GDP) in OECD members in 1990 to that in 1992?
Ensure brevity in your answer.  1.47. What is the ratio of the Oil Rent (as % of GDP) in Upper middle income in 1990 to that in 1992?
Provide a short and direct response. 1.72. What is the ratio of the Oil Rent (as % of GDP) in Guatemala in 1990 to that in 1992?
Your answer should be compact. 1.23. What is the ratio of the Oil Rent (as % of GDP) of Italy in 1990 to that in 1992?
Ensure brevity in your answer.  1.5. What is the ratio of the Oil Rent (as % of GDP) in OECD members in 1990 to that in 1993?
Make the answer very short. 1.74. What is the ratio of the Oil Rent (as % of GDP) in Upper middle income in 1990 to that in 1993?
Your answer should be compact. 1.73. What is the ratio of the Oil Rent (as % of GDP) in Guatemala in 1990 to that in 1993?
Ensure brevity in your answer.  1.29. What is the ratio of the Oil Rent (as % of GDP) in Italy in 1990 to that in 1993?
Provide a succinct answer. 1.35. What is the ratio of the Oil Rent (as % of GDP) in OECD members in 1990 to that in 1994?
Give a very brief answer. 1.9. What is the ratio of the Oil Rent (as % of GDP) of Upper middle income in 1990 to that in 1994?
Give a very brief answer. 2.07. What is the ratio of the Oil Rent (as % of GDP) in Guatemala in 1990 to that in 1994?
Provide a succinct answer. 1.44. What is the ratio of the Oil Rent (as % of GDP) of Italy in 1990 to that in 1994?
Your response must be concise. 1.41. What is the ratio of the Oil Rent (as % of GDP) in OECD members in 1991 to that in 1992?
Provide a succinct answer. 1.12. What is the ratio of the Oil Rent (as % of GDP) in Upper middle income in 1991 to that in 1992?
Provide a succinct answer. 1.03. What is the ratio of the Oil Rent (as % of GDP) of Guatemala in 1991 to that in 1992?
Provide a succinct answer. 0.76. What is the ratio of the Oil Rent (as % of GDP) in Italy in 1991 to that in 1992?
Offer a very short reply. 1.06. What is the ratio of the Oil Rent (as % of GDP) in OECD members in 1991 to that in 1993?
Provide a short and direct response. 1.32. What is the ratio of the Oil Rent (as % of GDP) of Upper middle income in 1991 to that in 1993?
Your answer should be very brief. 1.03. What is the ratio of the Oil Rent (as % of GDP) of Guatemala in 1991 to that in 1993?
Provide a succinct answer. 0.8. What is the ratio of the Oil Rent (as % of GDP) of Italy in 1991 to that in 1993?
Provide a short and direct response. 0.96. What is the ratio of the Oil Rent (as % of GDP) of OECD members in 1991 to that in 1994?
Offer a terse response. 1.45. What is the ratio of the Oil Rent (as % of GDP) of Upper middle income in 1991 to that in 1994?
Offer a terse response. 1.23. What is the ratio of the Oil Rent (as % of GDP) of Guatemala in 1991 to that in 1994?
Your response must be concise. 0.89. What is the ratio of the Oil Rent (as % of GDP) in Italy in 1991 to that in 1994?
Provide a succinct answer. 1. What is the ratio of the Oil Rent (as % of GDP) of OECD members in 1992 to that in 1993?
Provide a succinct answer. 1.18. What is the ratio of the Oil Rent (as % of GDP) of Upper middle income in 1992 to that in 1993?
Make the answer very short. 1. What is the ratio of the Oil Rent (as % of GDP) in Guatemala in 1992 to that in 1993?
Keep it short and to the point. 1.05. What is the ratio of the Oil Rent (as % of GDP) of Italy in 1992 to that in 1993?
Ensure brevity in your answer.  0.9. What is the ratio of the Oil Rent (as % of GDP) of OECD members in 1992 to that in 1994?
Offer a very short reply. 1.29. What is the ratio of the Oil Rent (as % of GDP) of Upper middle income in 1992 to that in 1994?
Provide a succinct answer. 1.2. What is the ratio of the Oil Rent (as % of GDP) in Guatemala in 1992 to that in 1994?
Make the answer very short. 1.17. What is the ratio of the Oil Rent (as % of GDP) in Italy in 1992 to that in 1994?
Your answer should be very brief. 0.94. What is the ratio of the Oil Rent (as % of GDP) in OECD members in 1993 to that in 1994?
Your response must be concise. 1.09. What is the ratio of the Oil Rent (as % of GDP) in Upper middle income in 1993 to that in 1994?
Offer a very short reply. 1.2. What is the ratio of the Oil Rent (as % of GDP) of Guatemala in 1993 to that in 1994?
Provide a succinct answer. 1.12. What is the ratio of the Oil Rent (as % of GDP) in Italy in 1993 to that in 1994?
Provide a succinct answer. 1.05. What is the difference between the highest and the second highest Oil Rent (as % of GDP) in OECD members?
Your answer should be very brief. 0.12. What is the difference between the highest and the second highest Oil Rent (as % of GDP) in Upper middle income?
Provide a succinct answer. 1.36. What is the difference between the highest and the second highest Oil Rent (as % of GDP) in Guatemala?
Offer a very short reply. 0.06. What is the difference between the highest and the second highest Oil Rent (as % of GDP) in Italy?
Your answer should be compact. 0.01. What is the difference between the highest and the lowest Oil Rent (as % of GDP) in OECD members?
Keep it short and to the point. 0.26. What is the difference between the highest and the lowest Oil Rent (as % of GDP) of Upper middle income?
Provide a succinct answer. 2.97. What is the difference between the highest and the lowest Oil Rent (as % of GDP) in Guatemala?
Your answer should be compact. 0.16. What is the difference between the highest and the lowest Oil Rent (as % of GDP) of Italy?
Keep it short and to the point. 0.02. 